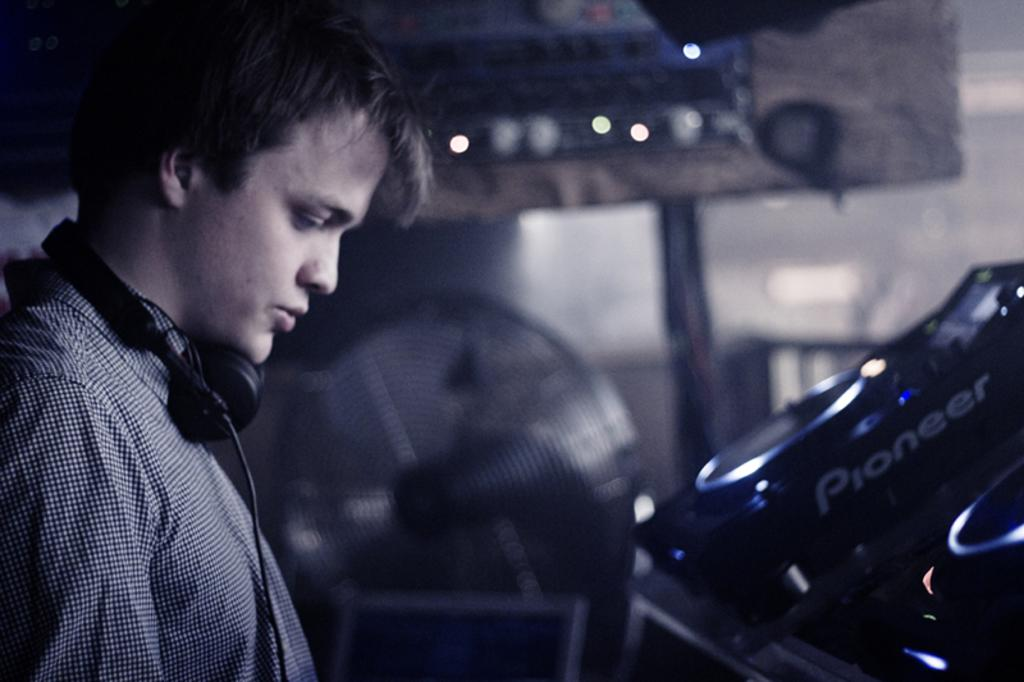What is the person in the image wearing on their head? The person in the image is wearing a headset. What can be seen in the background of the image? There are lights, a table fan, a vehicle, a board, and a wall visible in the background of the image. What type of shoes is the person wearing in the image? The image does not show the person's shoes, so it cannot be determined from the image. 